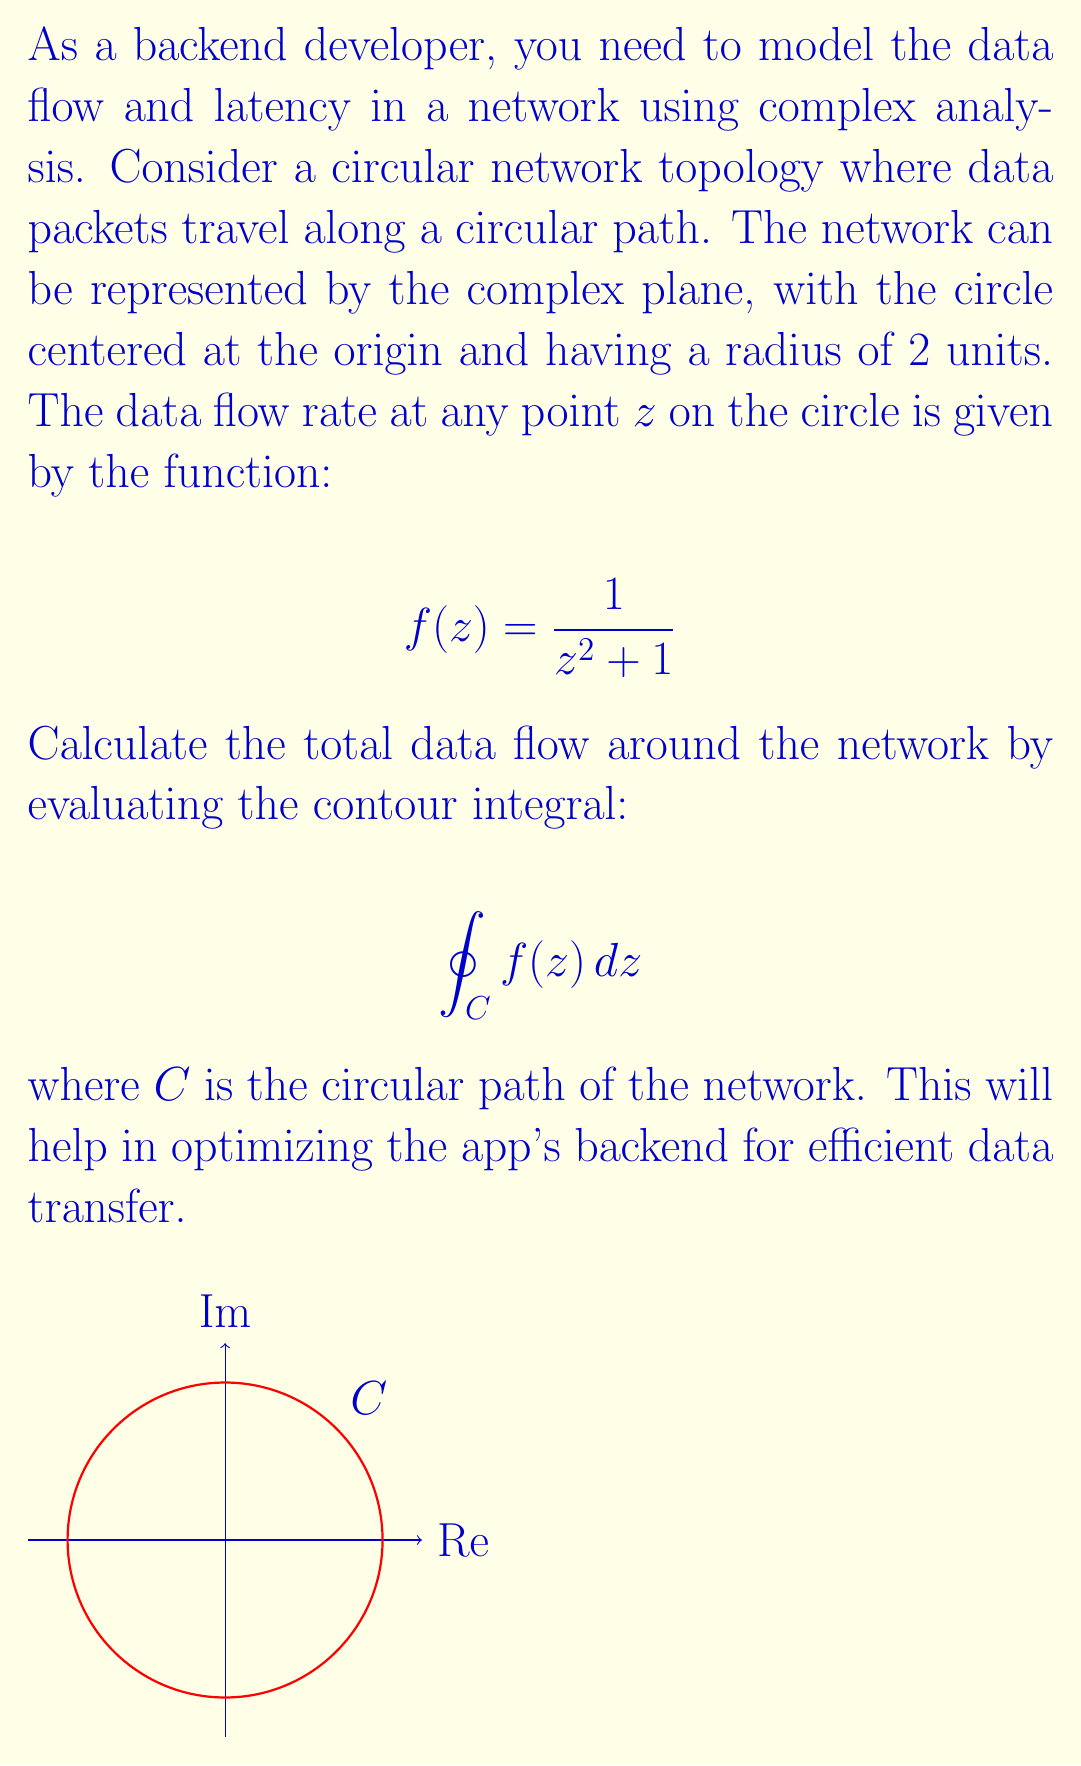Provide a solution to this math problem. To solve this contour integral, we'll follow these steps:

1) First, we need to check if there are any singularities inside the contour. The function $f(z) = \frac{1}{z^2 + 1}$ has poles at $z = \pm i$. Only $z = i$ is inside our contour.

2) We can use the Residue Theorem, which states:

   $$\oint_C f(z) dz = 2\pi i \sum \text{Res}(f, a_k)$$

   where $a_k$ are the poles of $f(z)$ inside the contour.

3) To find the residue at $z = i$, we use:

   $$\text{Res}(f, i) = \lim_{z \to i} (z-i)f(z) = \lim_{z \to i} \frac{z-i}{z^2+1}$$

4) Using L'Hôpital's rule:

   $$\text{Res}(f, i) = \lim_{z \to i} \frac{1}{2z} = \frac{1}{2i}$$

5) Applying the Residue Theorem:

   $$\oint_C f(z) dz = 2\pi i \cdot \frac{1}{2i} = \pi$$

Therefore, the total data flow around the network is $\pi$ units.
Answer: $\pi$ 